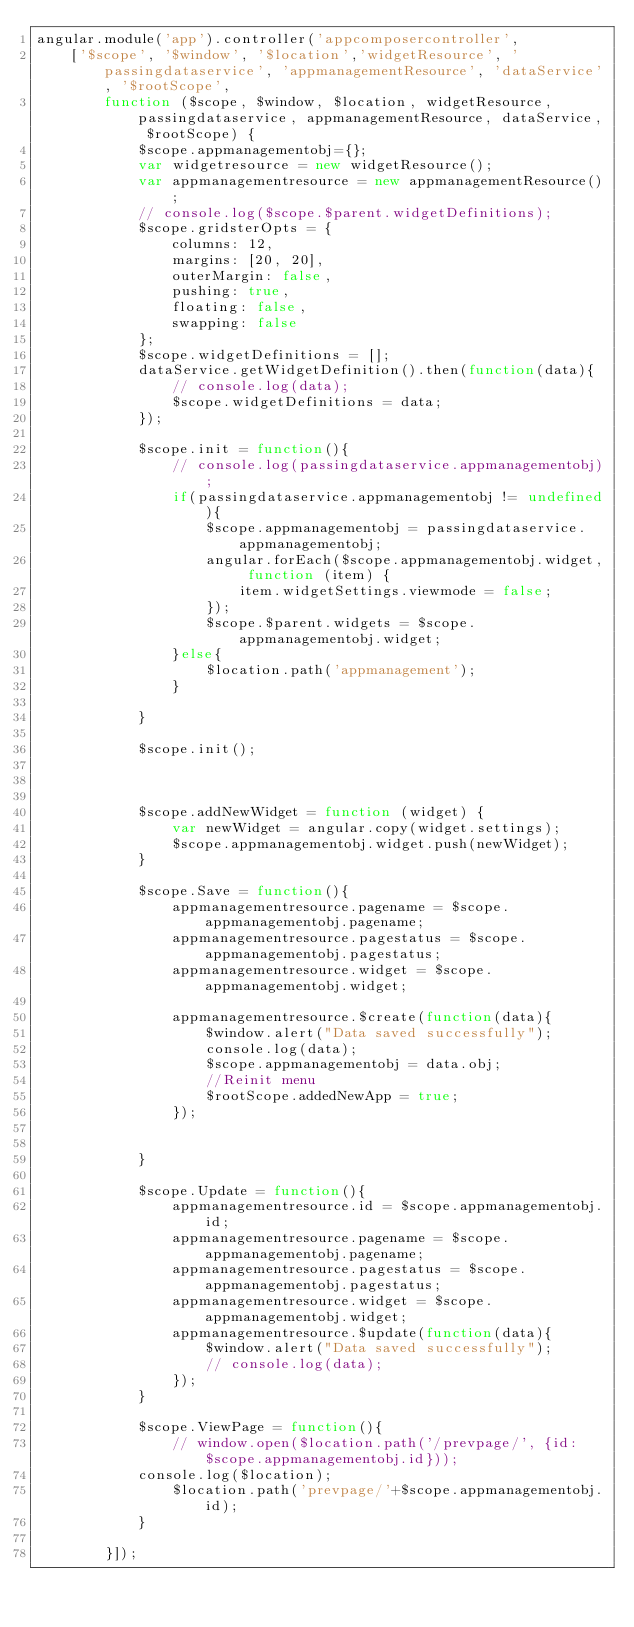<code> <loc_0><loc_0><loc_500><loc_500><_JavaScript_>angular.module('app').controller('appcomposercontroller',
    ['$scope', '$window', '$location','widgetResource', 'passingdataservice', 'appmanagementResource', 'dataService', '$rootScope',
        function ($scope, $window, $location, widgetResource, passingdataservice, appmanagementResource, dataService, $rootScope) {
            $scope.appmanagementobj={};
            var widgetresource = new widgetResource();
            var appmanagementresource = new appmanagementResource();
            // console.log($scope.$parent.widgetDefinitions);
            $scope.gridsterOpts = {
                columns: 12,
                margins: [20, 20],
                outerMargin: false,
                pushing: true,
                floating: false,
                swapping: false
            };
            $scope.widgetDefinitions = [];
            dataService.getWidgetDefinition().then(function(data){
                // console.log(data);
                $scope.widgetDefinitions = data;
            });

            $scope.init = function(){
                // console.log(passingdataservice.appmanagementobj);
                if(passingdataservice.appmanagementobj != undefined){
                    $scope.appmanagementobj = passingdataservice.appmanagementobj;
                    angular.forEach($scope.appmanagementobj.widget, function (item) {
                        item.widgetSettings.viewmode = false;
                    });
                    $scope.$parent.widgets = $scope.appmanagementobj.widget;
                }else{
                    $location.path('appmanagement');
                }

            }

            $scope.init();
            


            $scope.addNewWidget = function (widget) {
                var newWidget = angular.copy(widget.settings);
                $scope.appmanagementobj.widget.push(newWidget);
            }

            $scope.Save = function(){
                appmanagementresource.pagename = $scope.appmanagementobj.pagename;
                appmanagementresource.pagestatus = $scope.appmanagementobj.pagestatus;
                appmanagementresource.widget = $scope.appmanagementobj.widget;

                appmanagementresource.$create(function(data){
                    $window.alert("Data saved successfully");
                    console.log(data);
                    $scope.appmanagementobj = data.obj;
                    //Reinit menu
                    $rootScope.addedNewApp = true;
                });


            }

            $scope.Update = function(){
                appmanagementresource.id = $scope.appmanagementobj.id;
                appmanagementresource.pagename = $scope.appmanagementobj.pagename;
                appmanagementresource.pagestatus = $scope.appmanagementobj.pagestatus;
                appmanagementresource.widget = $scope.appmanagementobj.widget;
                appmanagementresource.$update(function(data){
                    $window.alert("Data saved successfully");
                    // console.log(data);
                });
            }
            
            $scope.ViewPage = function(){
                // window.open($location.path('/prevpage/', {id:$scope.appmanagementobj.id}));
            console.log($location);
                $location.path('prevpage/'+$scope.appmanagementobj.id);
            }

        }]);</code> 